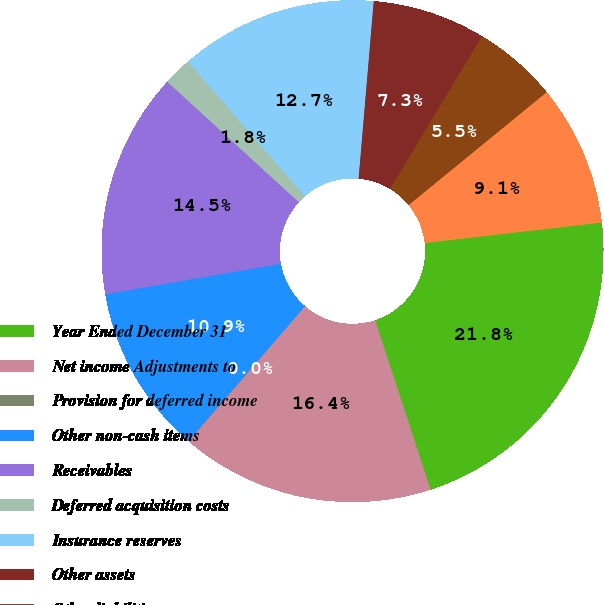<chart> <loc_0><loc_0><loc_500><loc_500><pie_chart><fcel>Year Ended December 31<fcel>Net income Adjustments to<fcel>Provision for deferred income<fcel>Other non-cash items<fcel>Receivables<fcel>Deferred acquisition costs<fcel>Insurance reserves<fcel>Other assets<fcel>Other liabilities<fcel>Trading securities<nl><fcel>21.79%<fcel>16.35%<fcel>0.02%<fcel>10.91%<fcel>14.54%<fcel>1.84%<fcel>12.72%<fcel>7.28%<fcel>5.46%<fcel>9.09%<nl></chart> 